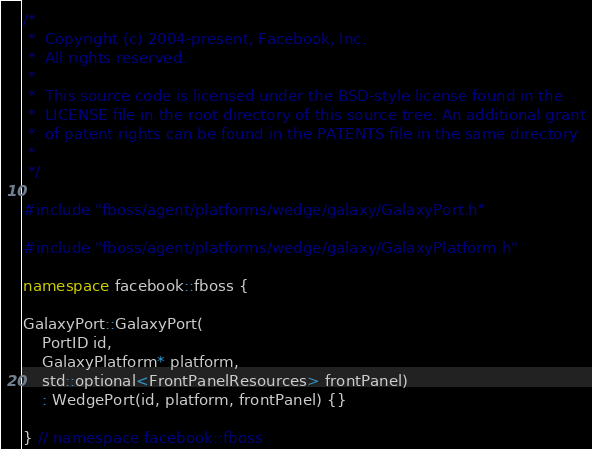Convert code to text. <code><loc_0><loc_0><loc_500><loc_500><_C++_>/*
 *  Copyright (c) 2004-present, Facebook, Inc.
 *  All rights reserved.
 *
 *  This source code is licensed under the BSD-style license found in the
 *  LICENSE file in the root directory of this source tree. An additional grant
 *  of patent rights can be found in the PATENTS file in the same directory.
 *
 */

#include "fboss/agent/platforms/wedge/galaxy/GalaxyPort.h"

#include "fboss/agent/platforms/wedge/galaxy/GalaxyPlatform.h"

namespace facebook::fboss {

GalaxyPort::GalaxyPort(
    PortID id,
    GalaxyPlatform* platform,
    std::optional<FrontPanelResources> frontPanel)
    : WedgePort(id, platform, frontPanel) {}

} // namespace facebook::fboss
</code> 